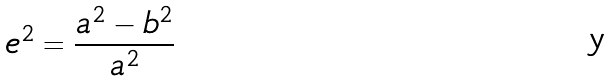Convert formula to latex. <formula><loc_0><loc_0><loc_500><loc_500>e ^ { 2 } = \frac { a ^ { 2 } - b ^ { 2 } } { a ^ { 2 } }</formula> 